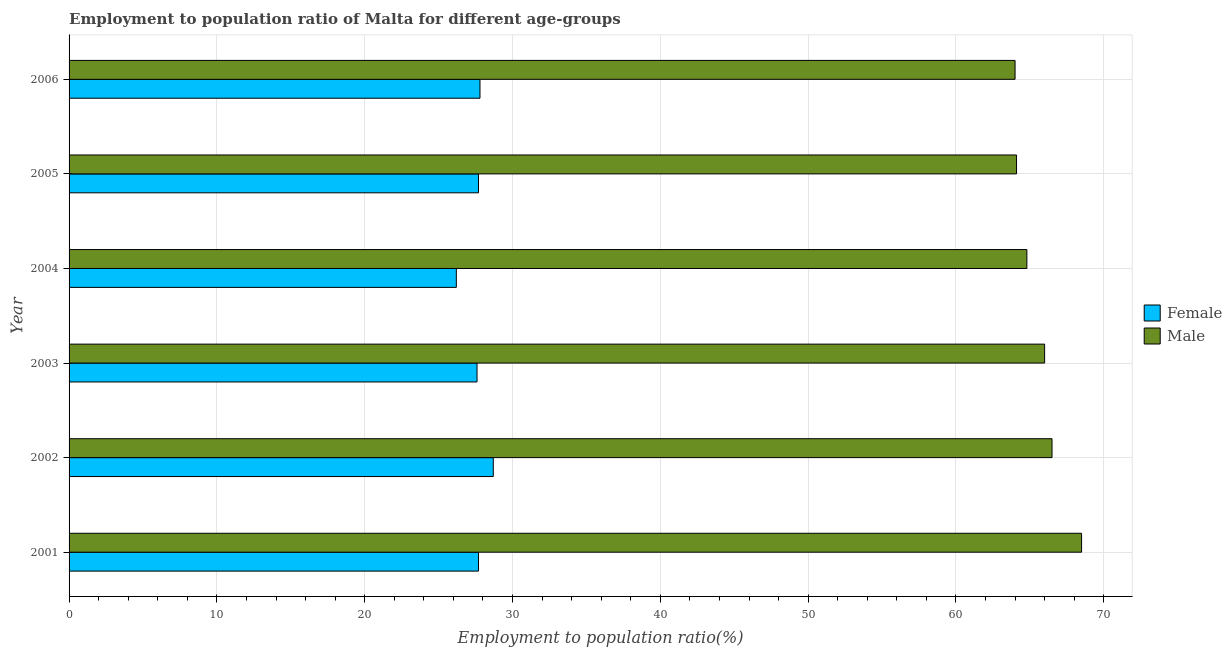How many different coloured bars are there?
Provide a short and direct response. 2. Are the number of bars on each tick of the Y-axis equal?
Offer a terse response. Yes. How many bars are there on the 6th tick from the top?
Offer a very short reply. 2. How many bars are there on the 5th tick from the bottom?
Give a very brief answer. 2. What is the label of the 1st group of bars from the top?
Ensure brevity in your answer.  2006. In how many cases, is the number of bars for a given year not equal to the number of legend labels?
Your answer should be compact. 0. What is the employment to population ratio(female) in 2003?
Offer a terse response. 27.6. Across all years, what is the maximum employment to population ratio(male)?
Offer a very short reply. 68.5. Across all years, what is the minimum employment to population ratio(male)?
Offer a very short reply. 64. What is the total employment to population ratio(male) in the graph?
Make the answer very short. 393.9. What is the difference between the employment to population ratio(male) in 2002 and the employment to population ratio(female) in 2001?
Provide a succinct answer. 38.8. What is the average employment to population ratio(male) per year?
Your answer should be compact. 65.65. In the year 2002, what is the difference between the employment to population ratio(female) and employment to population ratio(male)?
Your answer should be very brief. -37.8. In how many years, is the employment to population ratio(male) greater than 46 %?
Provide a short and direct response. 6. Is the employment to population ratio(male) in 2003 less than that in 2005?
Provide a short and direct response. No. Is the difference between the employment to population ratio(male) in 2003 and 2006 greater than the difference between the employment to population ratio(female) in 2003 and 2006?
Give a very brief answer. Yes. In how many years, is the employment to population ratio(female) greater than the average employment to population ratio(female) taken over all years?
Provide a short and direct response. 4. Is the sum of the employment to population ratio(male) in 2002 and 2003 greater than the maximum employment to population ratio(female) across all years?
Your answer should be very brief. Yes. What does the 2nd bar from the top in 2006 represents?
Offer a terse response. Female. How many bars are there?
Provide a short and direct response. 12. Does the graph contain any zero values?
Give a very brief answer. No. Where does the legend appear in the graph?
Ensure brevity in your answer.  Center right. What is the title of the graph?
Provide a succinct answer. Employment to population ratio of Malta for different age-groups. What is the Employment to population ratio(%) of Female in 2001?
Your response must be concise. 27.7. What is the Employment to population ratio(%) of Male in 2001?
Ensure brevity in your answer.  68.5. What is the Employment to population ratio(%) in Female in 2002?
Give a very brief answer. 28.7. What is the Employment to population ratio(%) in Male in 2002?
Provide a succinct answer. 66.5. What is the Employment to population ratio(%) of Female in 2003?
Ensure brevity in your answer.  27.6. What is the Employment to population ratio(%) of Male in 2003?
Keep it short and to the point. 66. What is the Employment to population ratio(%) in Female in 2004?
Ensure brevity in your answer.  26.2. What is the Employment to population ratio(%) of Male in 2004?
Offer a very short reply. 64.8. What is the Employment to population ratio(%) in Female in 2005?
Make the answer very short. 27.7. What is the Employment to population ratio(%) in Male in 2005?
Provide a succinct answer. 64.1. What is the Employment to population ratio(%) of Female in 2006?
Ensure brevity in your answer.  27.8. What is the Employment to population ratio(%) in Male in 2006?
Give a very brief answer. 64. Across all years, what is the maximum Employment to population ratio(%) of Female?
Your answer should be compact. 28.7. Across all years, what is the maximum Employment to population ratio(%) of Male?
Offer a terse response. 68.5. Across all years, what is the minimum Employment to population ratio(%) of Female?
Make the answer very short. 26.2. Across all years, what is the minimum Employment to population ratio(%) of Male?
Provide a short and direct response. 64. What is the total Employment to population ratio(%) of Female in the graph?
Give a very brief answer. 165.7. What is the total Employment to population ratio(%) in Male in the graph?
Provide a succinct answer. 393.9. What is the difference between the Employment to population ratio(%) in Male in 2001 and that in 2002?
Provide a short and direct response. 2. What is the difference between the Employment to population ratio(%) in Female in 2001 and that in 2003?
Your response must be concise. 0.1. What is the difference between the Employment to population ratio(%) of Male in 2001 and that in 2005?
Ensure brevity in your answer.  4.4. What is the difference between the Employment to population ratio(%) in Male in 2001 and that in 2006?
Make the answer very short. 4.5. What is the difference between the Employment to population ratio(%) of Female in 2002 and that in 2003?
Ensure brevity in your answer.  1.1. What is the difference between the Employment to population ratio(%) in Male in 2002 and that in 2003?
Make the answer very short. 0.5. What is the difference between the Employment to population ratio(%) of Female in 2002 and that in 2004?
Offer a terse response. 2.5. What is the difference between the Employment to population ratio(%) of Male in 2002 and that in 2005?
Make the answer very short. 2.4. What is the difference between the Employment to population ratio(%) of Female in 2003 and that in 2004?
Your answer should be compact. 1.4. What is the difference between the Employment to population ratio(%) in Male in 2003 and that in 2004?
Make the answer very short. 1.2. What is the difference between the Employment to population ratio(%) in Female in 2003 and that in 2005?
Keep it short and to the point. -0.1. What is the difference between the Employment to population ratio(%) in Male in 2003 and that in 2005?
Your answer should be very brief. 1.9. What is the difference between the Employment to population ratio(%) in Female in 2003 and that in 2006?
Make the answer very short. -0.2. What is the difference between the Employment to population ratio(%) in Male in 2003 and that in 2006?
Make the answer very short. 2. What is the difference between the Employment to population ratio(%) in Female in 2004 and that in 2005?
Your answer should be very brief. -1.5. What is the difference between the Employment to population ratio(%) in Male in 2004 and that in 2005?
Provide a succinct answer. 0.7. What is the difference between the Employment to population ratio(%) in Male in 2004 and that in 2006?
Your answer should be very brief. 0.8. What is the difference between the Employment to population ratio(%) of Female in 2005 and that in 2006?
Provide a short and direct response. -0.1. What is the difference between the Employment to population ratio(%) of Female in 2001 and the Employment to population ratio(%) of Male in 2002?
Provide a short and direct response. -38.8. What is the difference between the Employment to population ratio(%) of Female in 2001 and the Employment to population ratio(%) of Male in 2003?
Your answer should be very brief. -38.3. What is the difference between the Employment to population ratio(%) of Female in 2001 and the Employment to population ratio(%) of Male in 2004?
Your response must be concise. -37.1. What is the difference between the Employment to population ratio(%) in Female in 2001 and the Employment to population ratio(%) in Male in 2005?
Provide a succinct answer. -36.4. What is the difference between the Employment to population ratio(%) in Female in 2001 and the Employment to population ratio(%) in Male in 2006?
Give a very brief answer. -36.3. What is the difference between the Employment to population ratio(%) of Female in 2002 and the Employment to population ratio(%) of Male in 2003?
Your answer should be compact. -37.3. What is the difference between the Employment to population ratio(%) of Female in 2002 and the Employment to population ratio(%) of Male in 2004?
Provide a short and direct response. -36.1. What is the difference between the Employment to population ratio(%) of Female in 2002 and the Employment to population ratio(%) of Male in 2005?
Keep it short and to the point. -35.4. What is the difference between the Employment to population ratio(%) in Female in 2002 and the Employment to population ratio(%) in Male in 2006?
Your answer should be compact. -35.3. What is the difference between the Employment to population ratio(%) in Female in 2003 and the Employment to population ratio(%) in Male in 2004?
Give a very brief answer. -37.2. What is the difference between the Employment to population ratio(%) of Female in 2003 and the Employment to population ratio(%) of Male in 2005?
Your answer should be compact. -36.5. What is the difference between the Employment to population ratio(%) in Female in 2003 and the Employment to population ratio(%) in Male in 2006?
Offer a very short reply. -36.4. What is the difference between the Employment to population ratio(%) in Female in 2004 and the Employment to population ratio(%) in Male in 2005?
Your answer should be compact. -37.9. What is the difference between the Employment to population ratio(%) of Female in 2004 and the Employment to population ratio(%) of Male in 2006?
Your answer should be very brief. -37.8. What is the difference between the Employment to population ratio(%) in Female in 2005 and the Employment to population ratio(%) in Male in 2006?
Give a very brief answer. -36.3. What is the average Employment to population ratio(%) of Female per year?
Ensure brevity in your answer.  27.62. What is the average Employment to population ratio(%) of Male per year?
Keep it short and to the point. 65.65. In the year 2001, what is the difference between the Employment to population ratio(%) in Female and Employment to population ratio(%) in Male?
Give a very brief answer. -40.8. In the year 2002, what is the difference between the Employment to population ratio(%) of Female and Employment to population ratio(%) of Male?
Offer a very short reply. -37.8. In the year 2003, what is the difference between the Employment to population ratio(%) in Female and Employment to population ratio(%) in Male?
Give a very brief answer. -38.4. In the year 2004, what is the difference between the Employment to population ratio(%) of Female and Employment to population ratio(%) of Male?
Provide a short and direct response. -38.6. In the year 2005, what is the difference between the Employment to population ratio(%) of Female and Employment to population ratio(%) of Male?
Provide a short and direct response. -36.4. In the year 2006, what is the difference between the Employment to population ratio(%) of Female and Employment to population ratio(%) of Male?
Provide a short and direct response. -36.2. What is the ratio of the Employment to population ratio(%) of Female in 2001 to that in 2002?
Your answer should be compact. 0.97. What is the ratio of the Employment to population ratio(%) in Male in 2001 to that in 2002?
Your answer should be very brief. 1.03. What is the ratio of the Employment to population ratio(%) in Male in 2001 to that in 2003?
Provide a succinct answer. 1.04. What is the ratio of the Employment to population ratio(%) of Female in 2001 to that in 2004?
Offer a terse response. 1.06. What is the ratio of the Employment to population ratio(%) in Male in 2001 to that in 2004?
Ensure brevity in your answer.  1.06. What is the ratio of the Employment to population ratio(%) of Male in 2001 to that in 2005?
Keep it short and to the point. 1.07. What is the ratio of the Employment to population ratio(%) in Male in 2001 to that in 2006?
Your response must be concise. 1.07. What is the ratio of the Employment to population ratio(%) of Female in 2002 to that in 2003?
Give a very brief answer. 1.04. What is the ratio of the Employment to population ratio(%) of Male in 2002 to that in 2003?
Your response must be concise. 1.01. What is the ratio of the Employment to population ratio(%) of Female in 2002 to that in 2004?
Provide a succinct answer. 1.1. What is the ratio of the Employment to population ratio(%) in Male in 2002 to that in 2004?
Offer a terse response. 1.03. What is the ratio of the Employment to population ratio(%) of Female in 2002 to that in 2005?
Make the answer very short. 1.04. What is the ratio of the Employment to population ratio(%) in Male in 2002 to that in 2005?
Your answer should be very brief. 1.04. What is the ratio of the Employment to population ratio(%) in Female in 2002 to that in 2006?
Offer a terse response. 1.03. What is the ratio of the Employment to population ratio(%) of Male in 2002 to that in 2006?
Your answer should be very brief. 1.04. What is the ratio of the Employment to population ratio(%) of Female in 2003 to that in 2004?
Provide a short and direct response. 1.05. What is the ratio of the Employment to population ratio(%) of Male in 2003 to that in 2004?
Your answer should be compact. 1.02. What is the ratio of the Employment to population ratio(%) in Female in 2003 to that in 2005?
Offer a terse response. 1. What is the ratio of the Employment to population ratio(%) in Male in 2003 to that in 2005?
Offer a very short reply. 1.03. What is the ratio of the Employment to population ratio(%) of Male in 2003 to that in 2006?
Offer a very short reply. 1.03. What is the ratio of the Employment to population ratio(%) in Female in 2004 to that in 2005?
Provide a short and direct response. 0.95. What is the ratio of the Employment to population ratio(%) of Male in 2004 to that in 2005?
Ensure brevity in your answer.  1.01. What is the ratio of the Employment to population ratio(%) of Female in 2004 to that in 2006?
Your answer should be very brief. 0.94. What is the ratio of the Employment to population ratio(%) in Male in 2004 to that in 2006?
Provide a succinct answer. 1.01. What is the ratio of the Employment to population ratio(%) of Male in 2005 to that in 2006?
Ensure brevity in your answer.  1. What is the difference between the highest and the lowest Employment to population ratio(%) of Female?
Provide a succinct answer. 2.5. 